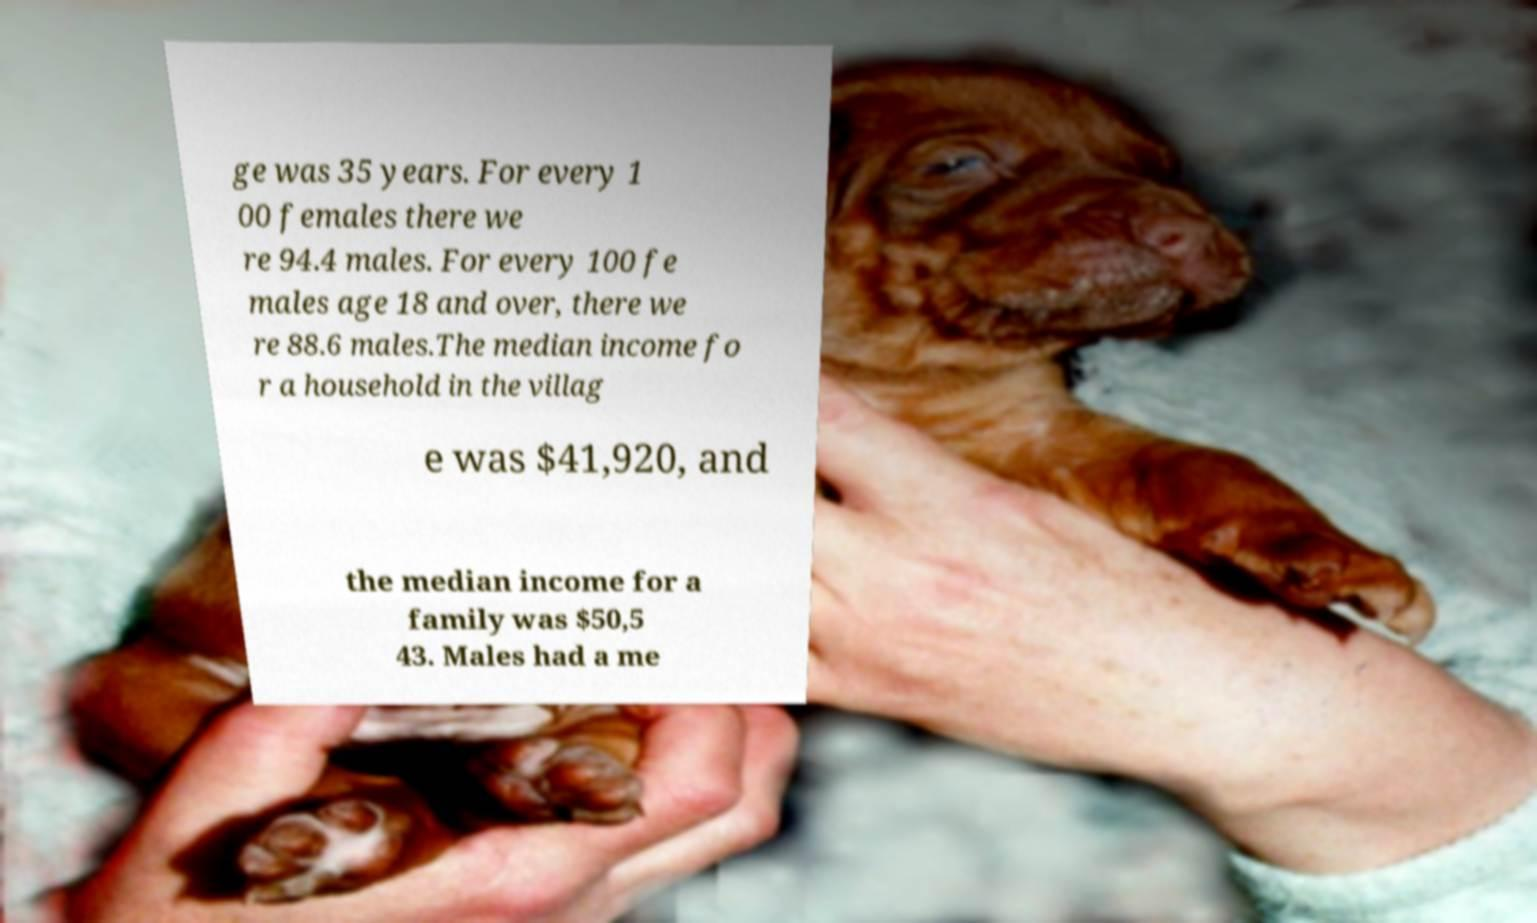Please read and relay the text visible in this image. What does it say? ge was 35 years. For every 1 00 females there we re 94.4 males. For every 100 fe males age 18 and over, there we re 88.6 males.The median income fo r a household in the villag e was $41,920, and the median income for a family was $50,5 43. Males had a me 